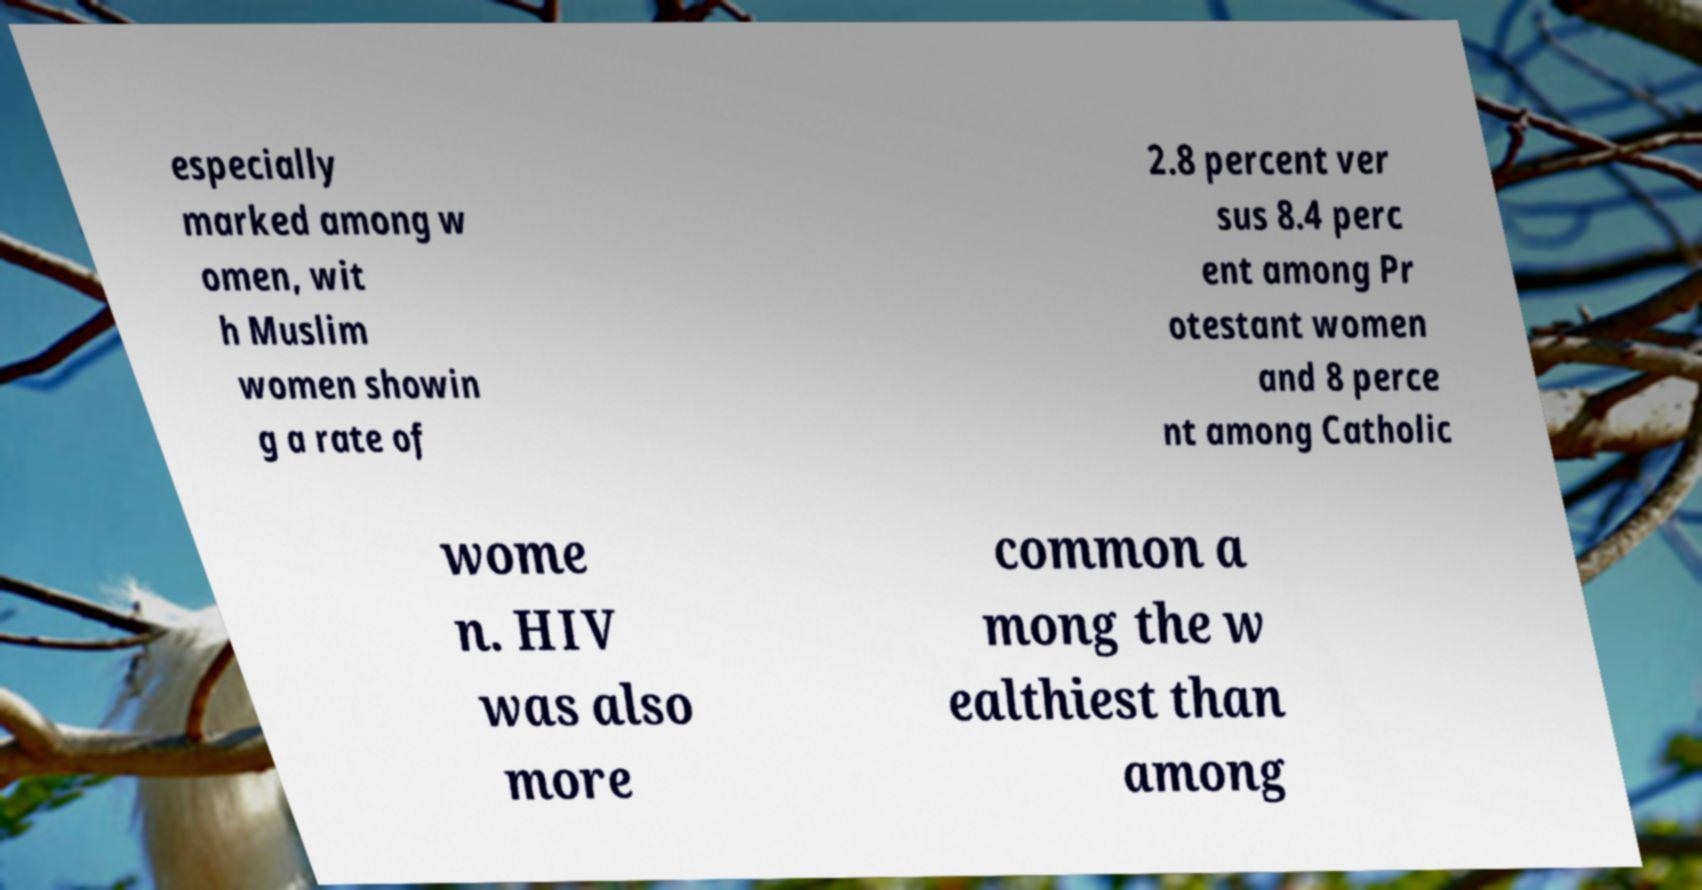I need the written content from this picture converted into text. Can you do that? especially marked among w omen, wit h Muslim women showin g a rate of 2.8 percent ver sus 8.4 perc ent among Pr otestant women and 8 perce nt among Catholic wome n. HIV was also more common a mong the w ealthiest than among 